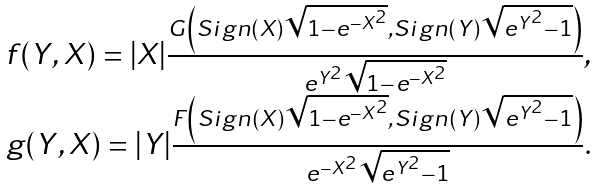Convert formula to latex. <formula><loc_0><loc_0><loc_500><loc_500>\begin{array} { c } f ( Y , X ) = | X | \frac { G \left ( S i g n ( X ) \sqrt { 1 - e ^ { - X ^ { 2 } } } , S i g n ( Y ) \sqrt { e ^ { Y ^ { 2 } } - 1 } \right ) } { e ^ { Y ^ { 2 } } \sqrt { 1 - e ^ { - X ^ { 2 } } } } , \\ g ( Y , X ) = | Y | \frac { F \left ( S i g n ( X ) \sqrt { 1 - e ^ { - X ^ { 2 } } } , S i g n ( Y ) \sqrt { e ^ { Y ^ { 2 } } - 1 } \right ) } { e ^ { - X ^ { 2 } } \sqrt { e ^ { Y ^ { 2 } } - 1 } } . \end{array}</formula> 